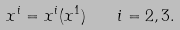<formula> <loc_0><loc_0><loc_500><loc_500>x ^ { i } = x ^ { i } ( x ^ { 1 } ) \quad i = 2 , 3 .</formula> 